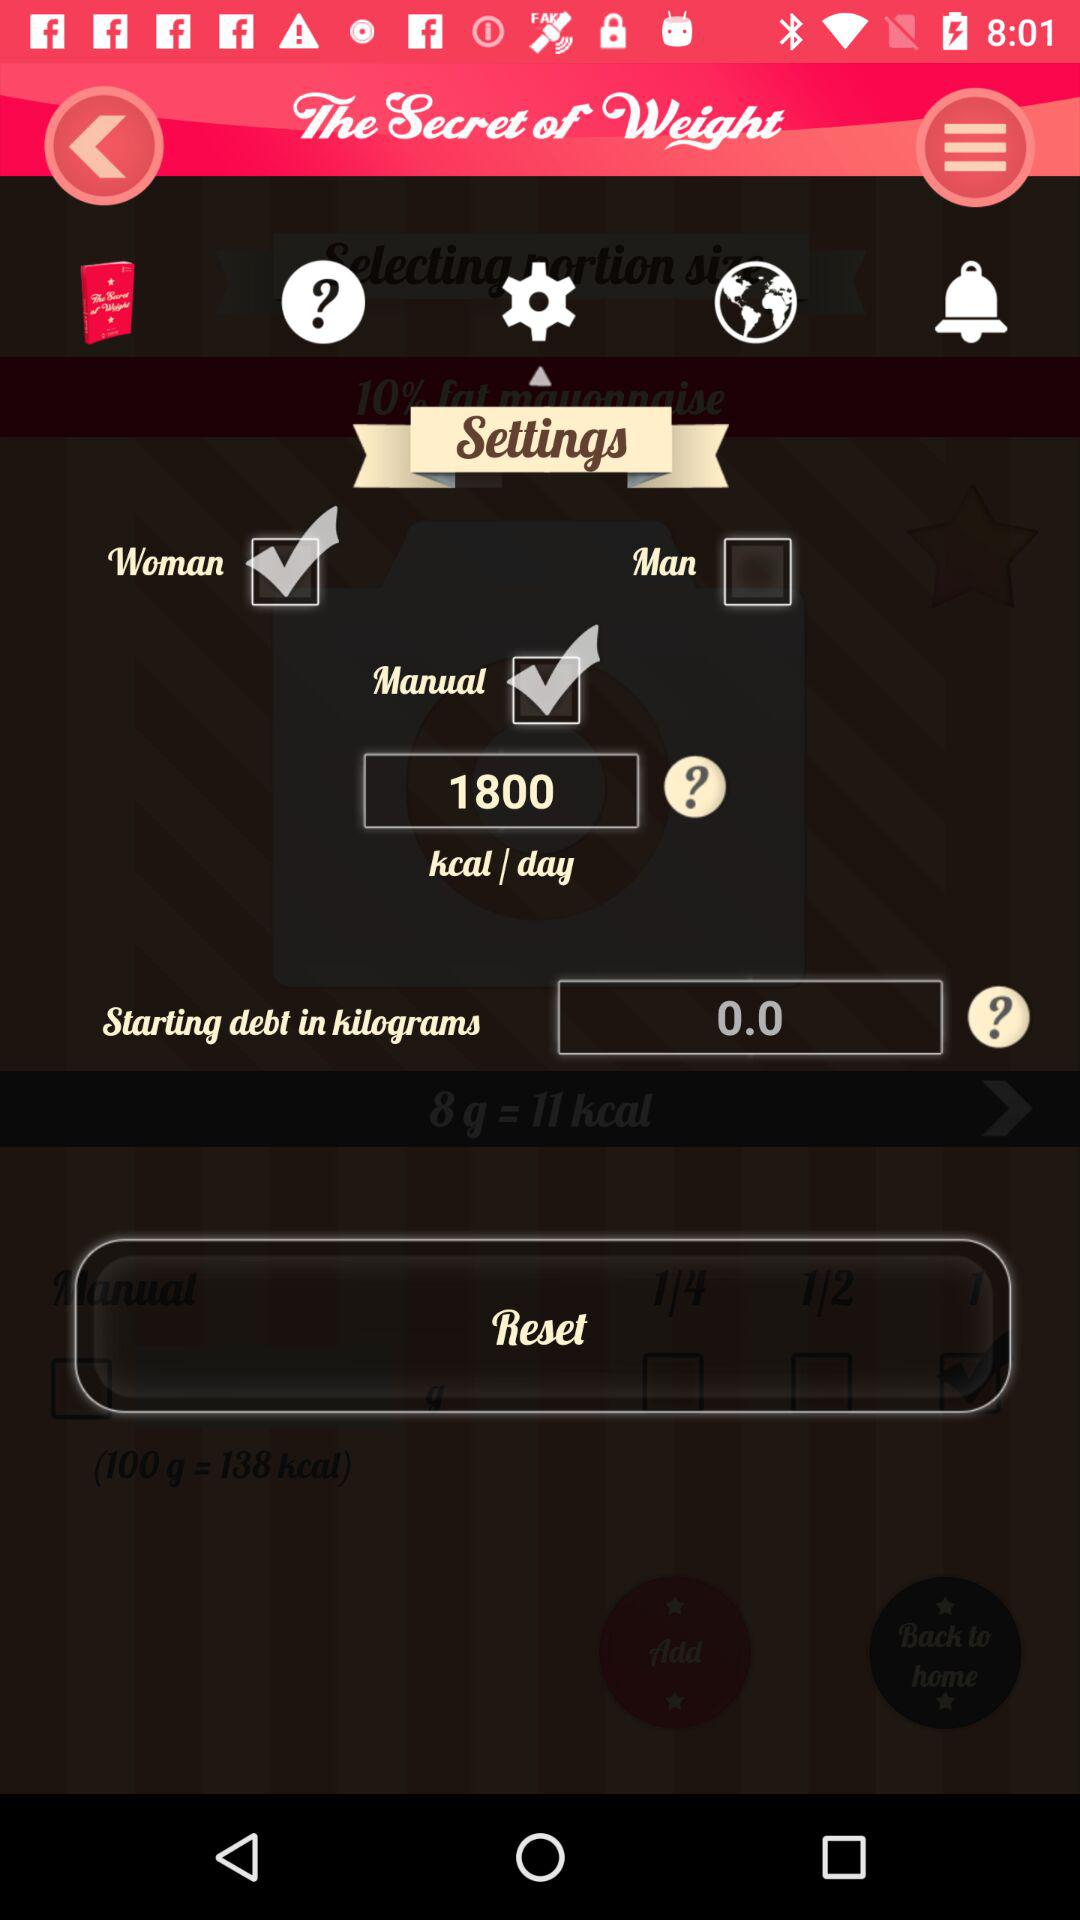Which gender is selected? The user is a woman. 